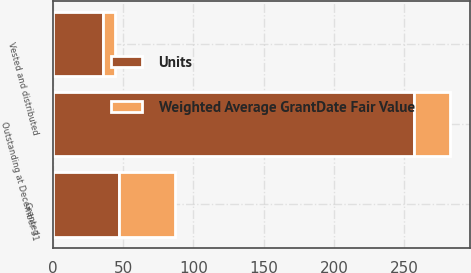Convert chart. <chart><loc_0><loc_0><loc_500><loc_500><stacked_bar_chart><ecel><fcel>Outstanding at December 31<fcel>Granted<fcel>Vested and distributed<nl><fcel>Units<fcel>257<fcel>47<fcel>36<nl><fcel>Weighted Average GrantDate Fair Value<fcel>25.31<fcel>39.86<fcel>7.96<nl></chart> 